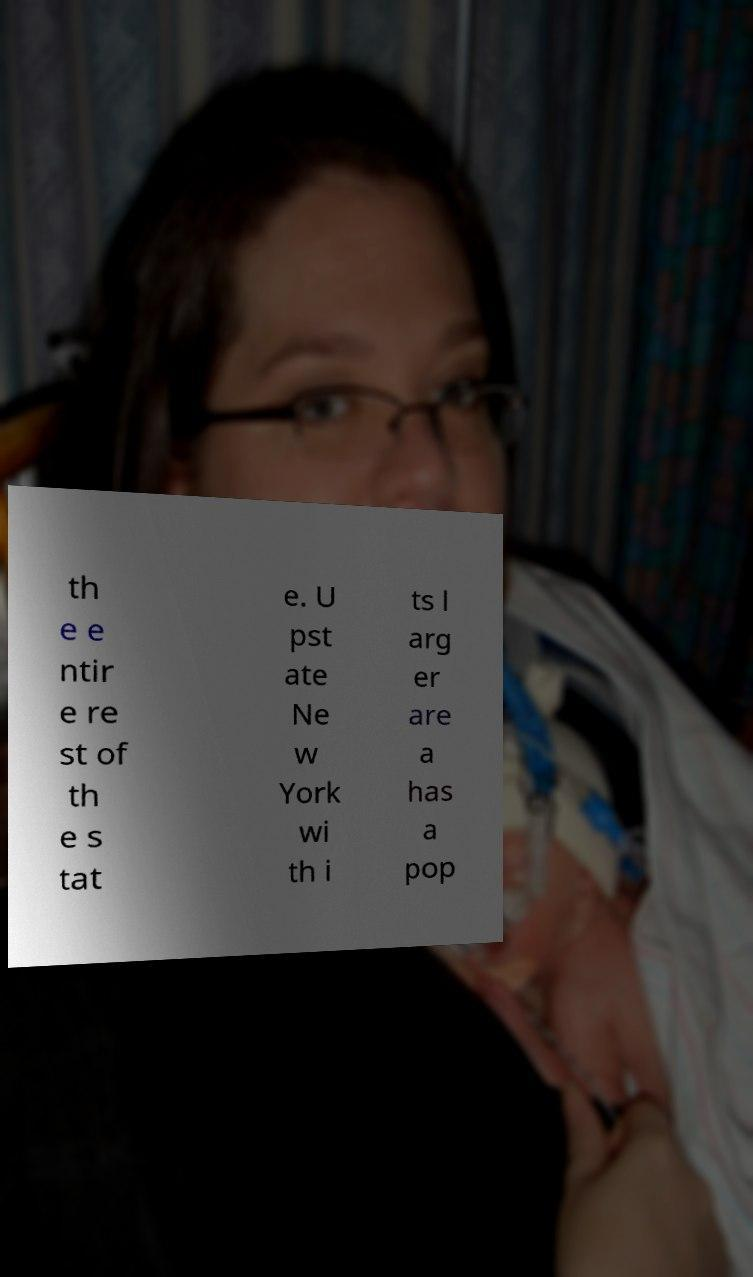I need the written content from this picture converted into text. Can you do that? th e e ntir e re st of th e s tat e. U pst ate Ne w York wi th i ts l arg er are a has a pop 